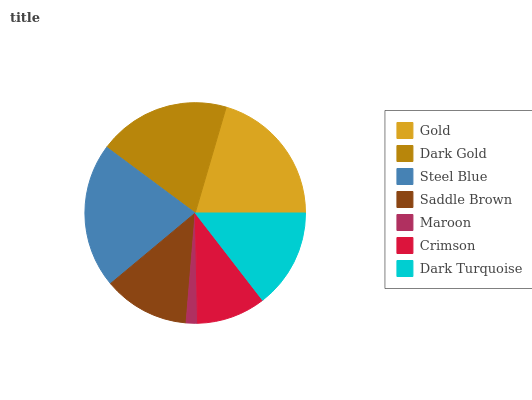Is Maroon the minimum?
Answer yes or no. Yes. Is Steel Blue the maximum?
Answer yes or no. Yes. Is Dark Gold the minimum?
Answer yes or no. No. Is Dark Gold the maximum?
Answer yes or no. No. Is Gold greater than Dark Gold?
Answer yes or no. Yes. Is Dark Gold less than Gold?
Answer yes or no. Yes. Is Dark Gold greater than Gold?
Answer yes or no. No. Is Gold less than Dark Gold?
Answer yes or no. No. Is Dark Turquoise the high median?
Answer yes or no. Yes. Is Dark Turquoise the low median?
Answer yes or no. Yes. Is Crimson the high median?
Answer yes or no. No. Is Dark Gold the low median?
Answer yes or no. No. 